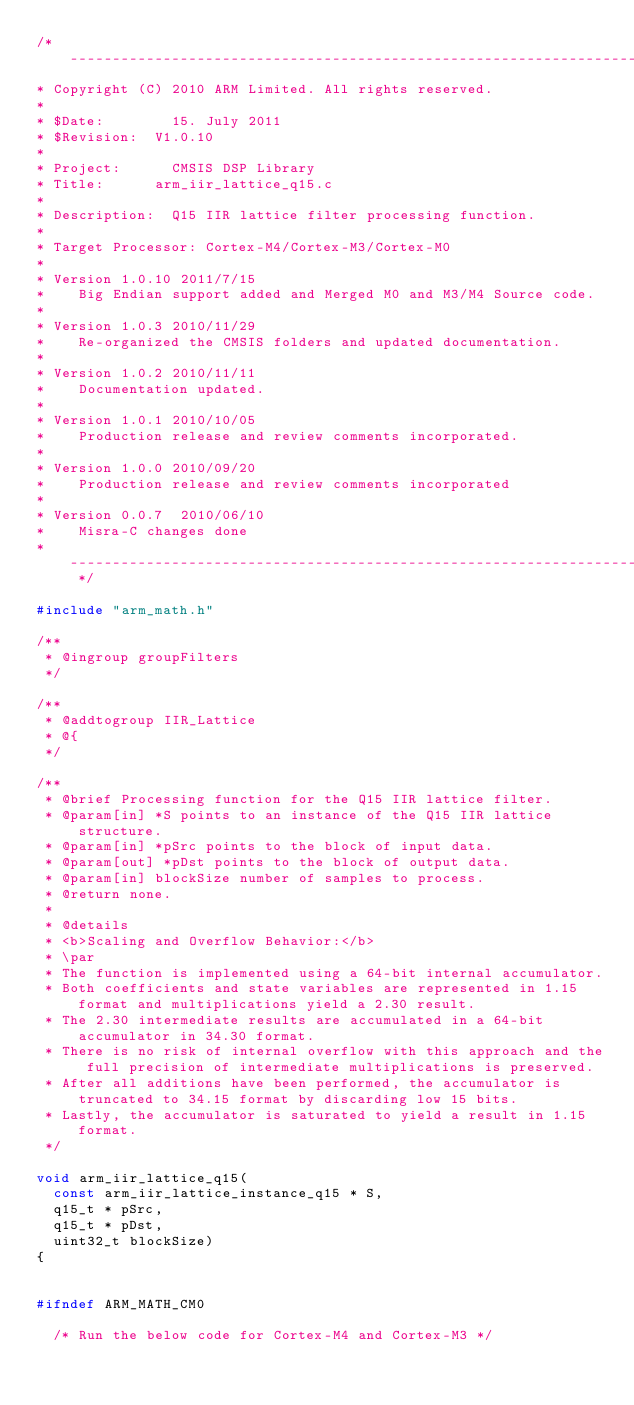Convert code to text. <code><loc_0><loc_0><loc_500><loc_500><_C_>/* ----------------------------------------------------------------------   
* Copyright (C) 2010 ARM Limited. All rights reserved.   
*   
* $Date:        15. July 2011  
* $Revision: 	V1.0.10  
*   
* Project: 	    CMSIS DSP Library   
* Title:	    arm_iir_lattice_q15.c   
*   
* Description:	Q15 IIR lattice filter processing function.   
*   
* Target Processor: Cortex-M4/Cortex-M3/Cortex-M0
*  
* Version 1.0.10 2011/7/15 
*    Big Endian support added and Merged M0 and M3/M4 Source code.  
*   
* Version 1.0.3 2010/11/29  
*    Re-organized the CMSIS folders and updated documentation.   
*    
* Version 1.0.2 2010/11/11   
*    Documentation updated.    
*   
* Version 1.0.1 2010/10/05    
*    Production release and review comments incorporated.   
*   
* Version 1.0.0 2010/09/20    
*    Production release and review comments incorporated   
*   
* Version 0.0.7  2010/06/10    
*    Misra-C changes done   
* -------------------------------------------------------------------- */

#include "arm_math.h"

/**   
 * @ingroup groupFilters   
 */

/**   
 * @addtogroup IIR_Lattice   
 * @{   
 */

/**   
 * @brief Processing function for the Q15 IIR lattice filter.   
 * @param[in] *S points to an instance of the Q15 IIR lattice structure.   
 * @param[in] *pSrc points to the block of input data.   
 * @param[out] *pDst points to the block of output data.   
 * @param[in] blockSize number of samples to process.   
 * @return none.   
 *   
 * @details   
 * <b>Scaling and Overflow Behavior:</b>   
 * \par   
 * The function is implemented using a 64-bit internal accumulator.   
 * Both coefficients and state variables are represented in 1.15 format and multiplications yield a 2.30 result.   
 * The 2.30 intermediate results are accumulated in a 64-bit accumulator in 34.30 format.   
 * There is no risk of internal overflow with this approach and the full precision of intermediate multiplications is preserved.   
 * After all additions have been performed, the accumulator is truncated to 34.15 format by discarding low 15 bits.   
 * Lastly, the accumulator is saturated to yield a result in 1.15 format.   
 */

void arm_iir_lattice_q15(
  const arm_iir_lattice_instance_q15 * S,
  q15_t * pSrc,
  q15_t * pDst,
  uint32_t blockSize)
{


#ifndef ARM_MATH_CM0

  /* Run the below code for Cortex-M4 and Cortex-M3 */
</code> 